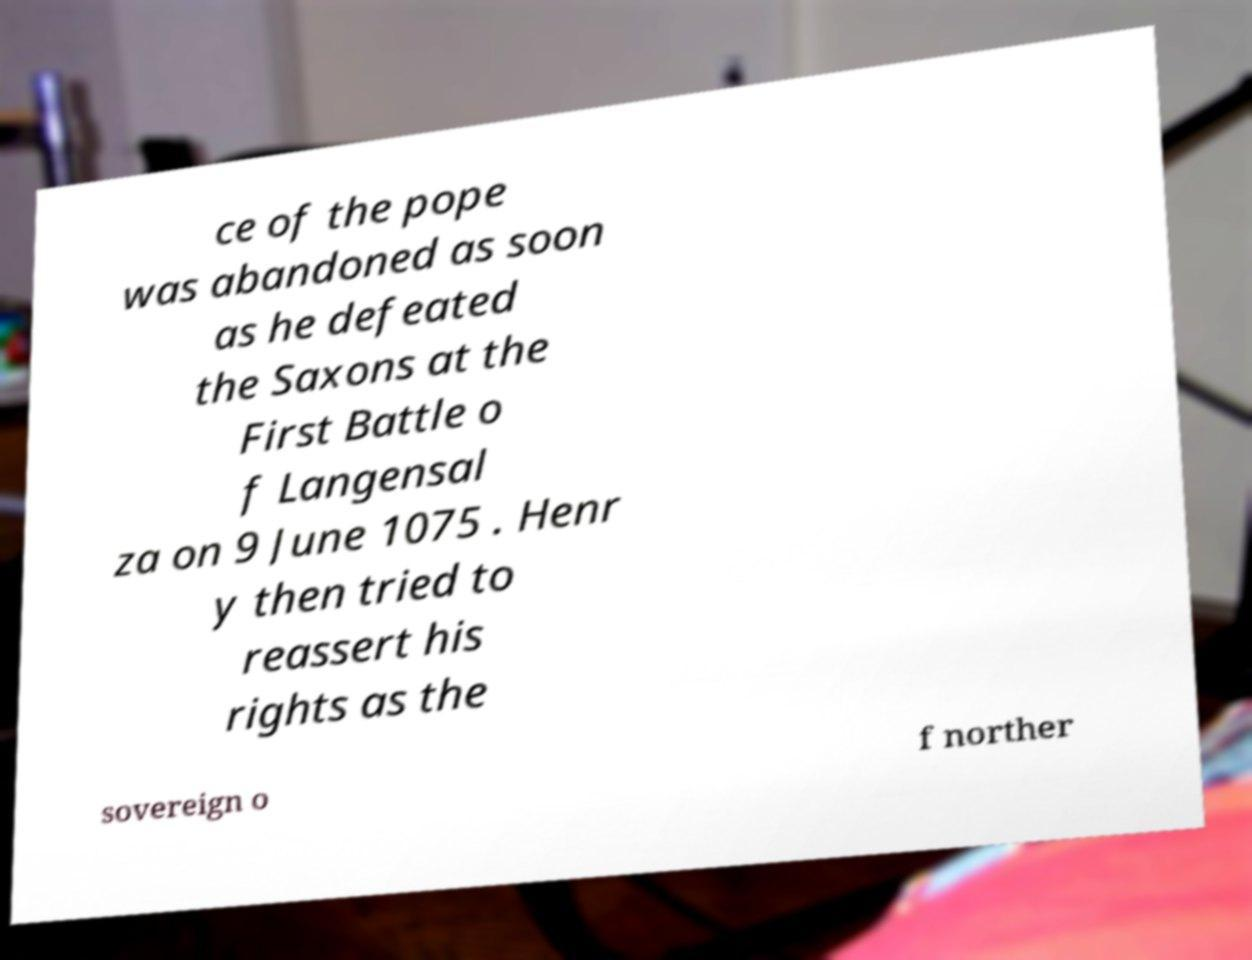For documentation purposes, I need the text within this image transcribed. Could you provide that? ce of the pope was abandoned as soon as he defeated the Saxons at the First Battle o f Langensal za on 9 June 1075 . Henr y then tried to reassert his rights as the sovereign o f norther 